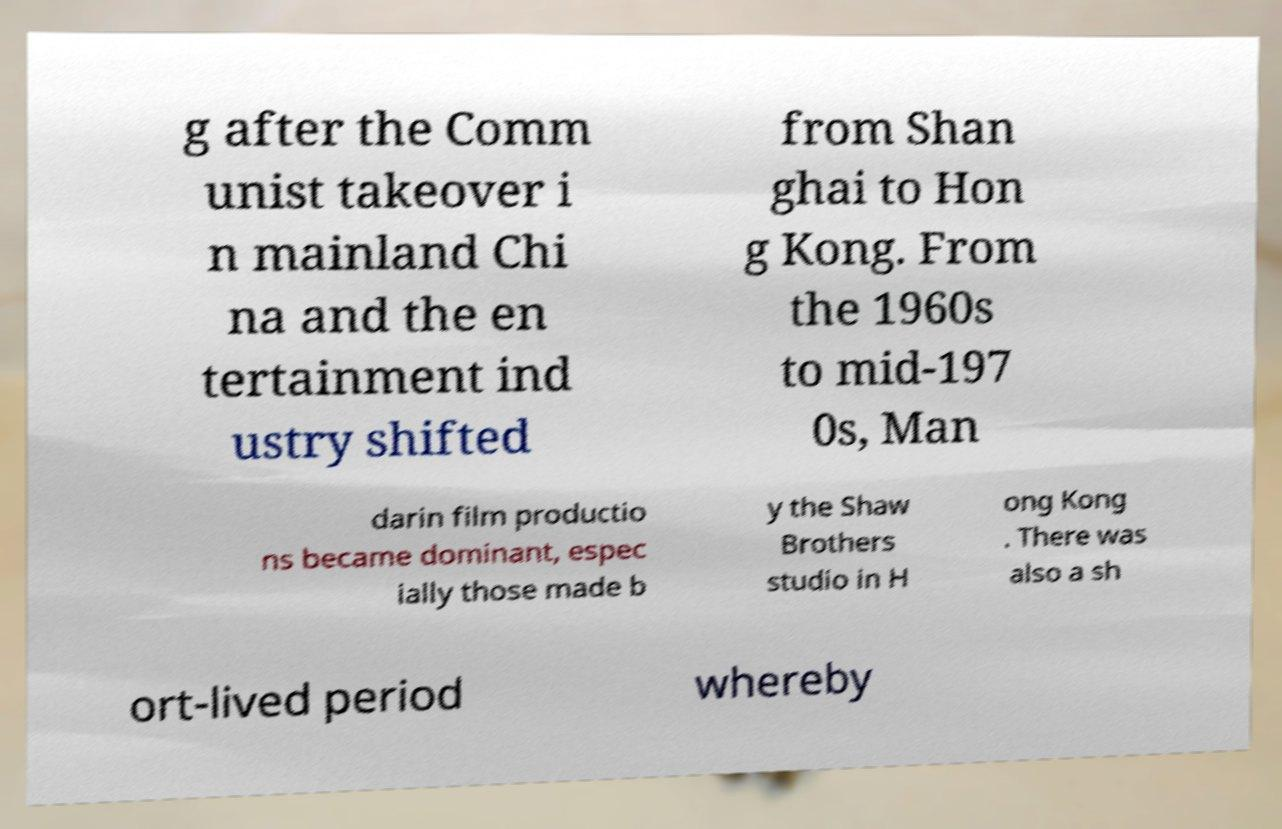Please identify and transcribe the text found in this image. g after the Comm unist takeover i n mainland Chi na and the en tertainment ind ustry shifted from Shan ghai to Hon g Kong. From the 1960s to mid-197 0s, Man darin film productio ns became dominant, espec ially those made b y the Shaw Brothers studio in H ong Kong . There was also a sh ort-lived period whereby 